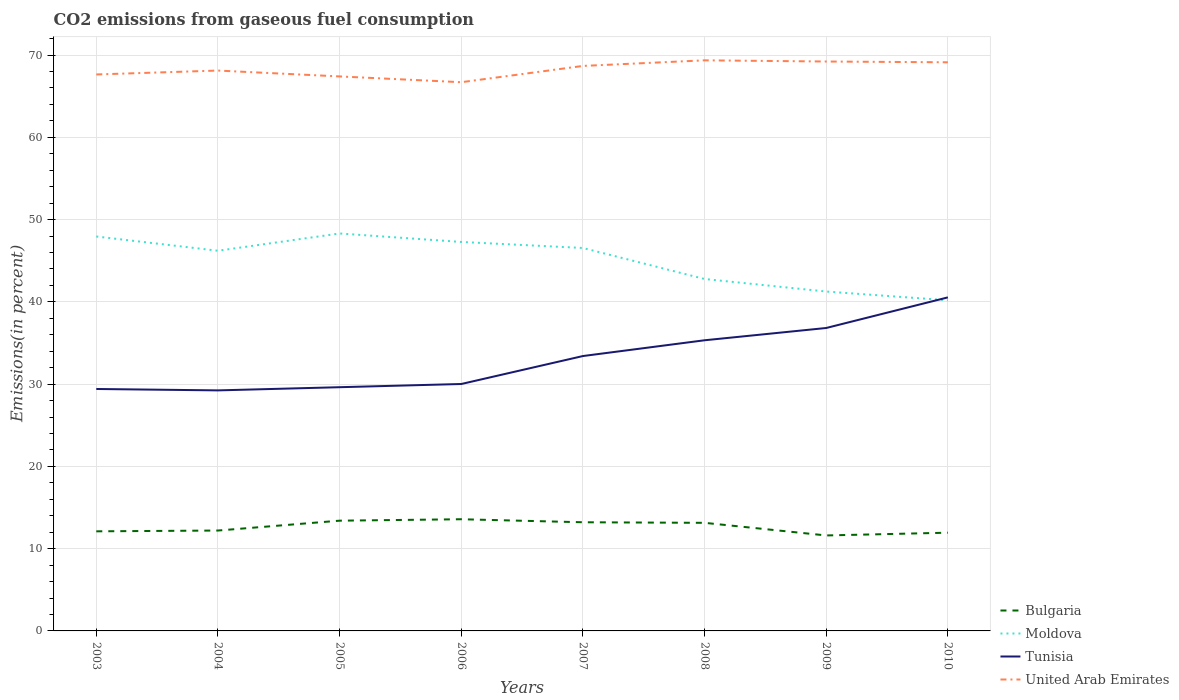Does the line corresponding to Tunisia intersect with the line corresponding to Moldova?
Ensure brevity in your answer.  Yes. Is the number of lines equal to the number of legend labels?
Your response must be concise. Yes. Across all years, what is the maximum total CO2 emitted in United Arab Emirates?
Offer a very short reply. 66.7. In which year was the total CO2 emitted in Moldova maximum?
Provide a short and direct response. 2010. What is the total total CO2 emitted in Tunisia in the graph?
Your answer should be very brief. -1.49. What is the difference between the highest and the second highest total CO2 emitted in Moldova?
Your answer should be compact. 8.12. What is the difference between the highest and the lowest total CO2 emitted in Moldova?
Offer a terse response. 5. How many lines are there?
Offer a very short reply. 4. Does the graph contain any zero values?
Ensure brevity in your answer.  No. How are the legend labels stacked?
Ensure brevity in your answer.  Vertical. What is the title of the graph?
Provide a succinct answer. CO2 emissions from gaseous fuel consumption. Does "Euro area" appear as one of the legend labels in the graph?
Keep it short and to the point. No. What is the label or title of the Y-axis?
Your answer should be compact. Emissions(in percent). What is the Emissions(in percent) in Bulgaria in 2003?
Ensure brevity in your answer.  12.11. What is the Emissions(in percent) of Moldova in 2003?
Offer a very short reply. 47.95. What is the Emissions(in percent) of Tunisia in 2003?
Ensure brevity in your answer.  29.41. What is the Emissions(in percent) in United Arab Emirates in 2003?
Keep it short and to the point. 67.64. What is the Emissions(in percent) in Bulgaria in 2004?
Offer a very short reply. 12.2. What is the Emissions(in percent) in Moldova in 2004?
Your answer should be compact. 46.22. What is the Emissions(in percent) in Tunisia in 2004?
Keep it short and to the point. 29.24. What is the Emissions(in percent) of United Arab Emirates in 2004?
Keep it short and to the point. 68.12. What is the Emissions(in percent) in Bulgaria in 2005?
Keep it short and to the point. 13.4. What is the Emissions(in percent) of Moldova in 2005?
Offer a terse response. 48.31. What is the Emissions(in percent) of Tunisia in 2005?
Provide a short and direct response. 29.63. What is the Emissions(in percent) in United Arab Emirates in 2005?
Your answer should be very brief. 67.41. What is the Emissions(in percent) of Bulgaria in 2006?
Your answer should be very brief. 13.58. What is the Emissions(in percent) in Moldova in 2006?
Make the answer very short. 47.28. What is the Emissions(in percent) in Tunisia in 2006?
Make the answer very short. 30.02. What is the Emissions(in percent) in United Arab Emirates in 2006?
Your answer should be compact. 66.7. What is the Emissions(in percent) of Bulgaria in 2007?
Give a very brief answer. 13.21. What is the Emissions(in percent) in Moldova in 2007?
Offer a terse response. 46.55. What is the Emissions(in percent) of Tunisia in 2007?
Your answer should be compact. 33.41. What is the Emissions(in percent) in United Arab Emirates in 2007?
Provide a succinct answer. 68.68. What is the Emissions(in percent) of Bulgaria in 2008?
Offer a terse response. 13.14. What is the Emissions(in percent) in Moldova in 2008?
Your answer should be compact. 42.78. What is the Emissions(in percent) of Tunisia in 2008?
Give a very brief answer. 35.33. What is the Emissions(in percent) in United Arab Emirates in 2008?
Make the answer very short. 69.36. What is the Emissions(in percent) in Bulgaria in 2009?
Ensure brevity in your answer.  11.61. What is the Emissions(in percent) in Moldova in 2009?
Your answer should be very brief. 41.26. What is the Emissions(in percent) of Tunisia in 2009?
Keep it short and to the point. 36.82. What is the Emissions(in percent) in United Arab Emirates in 2009?
Give a very brief answer. 69.22. What is the Emissions(in percent) of Bulgaria in 2010?
Offer a terse response. 11.94. What is the Emissions(in percent) of Moldova in 2010?
Provide a short and direct response. 40.19. What is the Emissions(in percent) in Tunisia in 2010?
Make the answer very short. 40.55. What is the Emissions(in percent) of United Arab Emirates in 2010?
Make the answer very short. 69.12. Across all years, what is the maximum Emissions(in percent) in Bulgaria?
Your answer should be very brief. 13.58. Across all years, what is the maximum Emissions(in percent) of Moldova?
Your response must be concise. 48.31. Across all years, what is the maximum Emissions(in percent) in Tunisia?
Provide a succinct answer. 40.55. Across all years, what is the maximum Emissions(in percent) of United Arab Emirates?
Offer a very short reply. 69.36. Across all years, what is the minimum Emissions(in percent) in Bulgaria?
Offer a terse response. 11.61. Across all years, what is the minimum Emissions(in percent) in Moldova?
Your answer should be very brief. 40.19. Across all years, what is the minimum Emissions(in percent) in Tunisia?
Your response must be concise. 29.24. Across all years, what is the minimum Emissions(in percent) of United Arab Emirates?
Give a very brief answer. 66.7. What is the total Emissions(in percent) in Bulgaria in the graph?
Offer a terse response. 101.19. What is the total Emissions(in percent) in Moldova in the graph?
Provide a short and direct response. 360.54. What is the total Emissions(in percent) of Tunisia in the graph?
Your answer should be very brief. 264.41. What is the total Emissions(in percent) of United Arab Emirates in the graph?
Your answer should be very brief. 546.26. What is the difference between the Emissions(in percent) of Bulgaria in 2003 and that in 2004?
Offer a terse response. -0.1. What is the difference between the Emissions(in percent) in Moldova in 2003 and that in 2004?
Keep it short and to the point. 1.73. What is the difference between the Emissions(in percent) in Tunisia in 2003 and that in 2004?
Your answer should be very brief. 0.17. What is the difference between the Emissions(in percent) in United Arab Emirates in 2003 and that in 2004?
Provide a short and direct response. -0.47. What is the difference between the Emissions(in percent) in Bulgaria in 2003 and that in 2005?
Give a very brief answer. -1.29. What is the difference between the Emissions(in percent) in Moldova in 2003 and that in 2005?
Provide a succinct answer. -0.37. What is the difference between the Emissions(in percent) in Tunisia in 2003 and that in 2005?
Keep it short and to the point. -0.22. What is the difference between the Emissions(in percent) of United Arab Emirates in 2003 and that in 2005?
Offer a terse response. 0.24. What is the difference between the Emissions(in percent) in Bulgaria in 2003 and that in 2006?
Give a very brief answer. -1.47. What is the difference between the Emissions(in percent) of Moldova in 2003 and that in 2006?
Provide a short and direct response. 0.67. What is the difference between the Emissions(in percent) of Tunisia in 2003 and that in 2006?
Provide a succinct answer. -0.61. What is the difference between the Emissions(in percent) in United Arab Emirates in 2003 and that in 2006?
Keep it short and to the point. 0.94. What is the difference between the Emissions(in percent) of Bulgaria in 2003 and that in 2007?
Provide a short and direct response. -1.1. What is the difference between the Emissions(in percent) of Moldova in 2003 and that in 2007?
Offer a terse response. 1.4. What is the difference between the Emissions(in percent) of Tunisia in 2003 and that in 2007?
Provide a succinct answer. -4. What is the difference between the Emissions(in percent) in United Arab Emirates in 2003 and that in 2007?
Ensure brevity in your answer.  -1.04. What is the difference between the Emissions(in percent) of Bulgaria in 2003 and that in 2008?
Your answer should be very brief. -1.03. What is the difference between the Emissions(in percent) in Moldova in 2003 and that in 2008?
Ensure brevity in your answer.  5.17. What is the difference between the Emissions(in percent) of Tunisia in 2003 and that in 2008?
Your answer should be very brief. -5.92. What is the difference between the Emissions(in percent) in United Arab Emirates in 2003 and that in 2008?
Give a very brief answer. -1.72. What is the difference between the Emissions(in percent) of Bulgaria in 2003 and that in 2009?
Give a very brief answer. 0.5. What is the difference between the Emissions(in percent) in Moldova in 2003 and that in 2009?
Your answer should be very brief. 6.69. What is the difference between the Emissions(in percent) in Tunisia in 2003 and that in 2009?
Offer a terse response. -7.42. What is the difference between the Emissions(in percent) of United Arab Emirates in 2003 and that in 2009?
Your answer should be very brief. -1.57. What is the difference between the Emissions(in percent) of Bulgaria in 2003 and that in 2010?
Ensure brevity in your answer.  0.17. What is the difference between the Emissions(in percent) in Moldova in 2003 and that in 2010?
Your answer should be very brief. 7.76. What is the difference between the Emissions(in percent) in Tunisia in 2003 and that in 2010?
Make the answer very short. -11.14. What is the difference between the Emissions(in percent) in United Arab Emirates in 2003 and that in 2010?
Ensure brevity in your answer.  -1.48. What is the difference between the Emissions(in percent) of Bulgaria in 2004 and that in 2005?
Your response must be concise. -1.2. What is the difference between the Emissions(in percent) of Moldova in 2004 and that in 2005?
Your answer should be very brief. -2.1. What is the difference between the Emissions(in percent) in Tunisia in 2004 and that in 2005?
Ensure brevity in your answer.  -0.39. What is the difference between the Emissions(in percent) of United Arab Emirates in 2004 and that in 2005?
Make the answer very short. 0.71. What is the difference between the Emissions(in percent) of Bulgaria in 2004 and that in 2006?
Make the answer very short. -1.37. What is the difference between the Emissions(in percent) of Moldova in 2004 and that in 2006?
Offer a very short reply. -1.07. What is the difference between the Emissions(in percent) of Tunisia in 2004 and that in 2006?
Your response must be concise. -0.78. What is the difference between the Emissions(in percent) in United Arab Emirates in 2004 and that in 2006?
Your response must be concise. 1.42. What is the difference between the Emissions(in percent) of Bulgaria in 2004 and that in 2007?
Give a very brief answer. -1.01. What is the difference between the Emissions(in percent) in Moldova in 2004 and that in 2007?
Keep it short and to the point. -0.34. What is the difference between the Emissions(in percent) of Tunisia in 2004 and that in 2007?
Offer a very short reply. -4.18. What is the difference between the Emissions(in percent) in United Arab Emirates in 2004 and that in 2007?
Your response must be concise. -0.56. What is the difference between the Emissions(in percent) of Bulgaria in 2004 and that in 2008?
Provide a succinct answer. -0.94. What is the difference between the Emissions(in percent) in Moldova in 2004 and that in 2008?
Provide a short and direct response. 3.44. What is the difference between the Emissions(in percent) of Tunisia in 2004 and that in 2008?
Provide a succinct answer. -6.09. What is the difference between the Emissions(in percent) of United Arab Emirates in 2004 and that in 2008?
Keep it short and to the point. -1.24. What is the difference between the Emissions(in percent) of Bulgaria in 2004 and that in 2009?
Keep it short and to the point. 0.6. What is the difference between the Emissions(in percent) of Moldova in 2004 and that in 2009?
Give a very brief answer. 4.96. What is the difference between the Emissions(in percent) in Tunisia in 2004 and that in 2009?
Provide a short and direct response. -7.59. What is the difference between the Emissions(in percent) in United Arab Emirates in 2004 and that in 2009?
Offer a terse response. -1.1. What is the difference between the Emissions(in percent) of Bulgaria in 2004 and that in 2010?
Give a very brief answer. 0.26. What is the difference between the Emissions(in percent) of Moldova in 2004 and that in 2010?
Ensure brevity in your answer.  6.02. What is the difference between the Emissions(in percent) of Tunisia in 2004 and that in 2010?
Offer a terse response. -11.31. What is the difference between the Emissions(in percent) in United Arab Emirates in 2004 and that in 2010?
Keep it short and to the point. -1. What is the difference between the Emissions(in percent) of Bulgaria in 2005 and that in 2006?
Offer a terse response. -0.17. What is the difference between the Emissions(in percent) of Moldova in 2005 and that in 2006?
Ensure brevity in your answer.  1.03. What is the difference between the Emissions(in percent) of Tunisia in 2005 and that in 2006?
Provide a short and direct response. -0.39. What is the difference between the Emissions(in percent) in United Arab Emirates in 2005 and that in 2006?
Offer a very short reply. 0.7. What is the difference between the Emissions(in percent) in Bulgaria in 2005 and that in 2007?
Your answer should be very brief. 0.19. What is the difference between the Emissions(in percent) of Moldova in 2005 and that in 2007?
Provide a short and direct response. 1.76. What is the difference between the Emissions(in percent) in Tunisia in 2005 and that in 2007?
Offer a very short reply. -3.79. What is the difference between the Emissions(in percent) of United Arab Emirates in 2005 and that in 2007?
Ensure brevity in your answer.  -1.28. What is the difference between the Emissions(in percent) in Bulgaria in 2005 and that in 2008?
Give a very brief answer. 0.26. What is the difference between the Emissions(in percent) of Moldova in 2005 and that in 2008?
Provide a succinct answer. 5.53. What is the difference between the Emissions(in percent) in Tunisia in 2005 and that in 2008?
Provide a short and direct response. -5.7. What is the difference between the Emissions(in percent) of United Arab Emirates in 2005 and that in 2008?
Your answer should be very brief. -1.96. What is the difference between the Emissions(in percent) of Bulgaria in 2005 and that in 2009?
Provide a short and direct response. 1.8. What is the difference between the Emissions(in percent) of Moldova in 2005 and that in 2009?
Make the answer very short. 7.06. What is the difference between the Emissions(in percent) of Tunisia in 2005 and that in 2009?
Your response must be concise. -7.2. What is the difference between the Emissions(in percent) of United Arab Emirates in 2005 and that in 2009?
Provide a short and direct response. -1.81. What is the difference between the Emissions(in percent) in Bulgaria in 2005 and that in 2010?
Give a very brief answer. 1.46. What is the difference between the Emissions(in percent) in Moldova in 2005 and that in 2010?
Your answer should be very brief. 8.12. What is the difference between the Emissions(in percent) of Tunisia in 2005 and that in 2010?
Provide a short and direct response. -10.92. What is the difference between the Emissions(in percent) of United Arab Emirates in 2005 and that in 2010?
Ensure brevity in your answer.  -1.72. What is the difference between the Emissions(in percent) in Bulgaria in 2006 and that in 2007?
Your response must be concise. 0.37. What is the difference between the Emissions(in percent) of Moldova in 2006 and that in 2007?
Your answer should be very brief. 0.73. What is the difference between the Emissions(in percent) of Tunisia in 2006 and that in 2007?
Offer a very short reply. -3.4. What is the difference between the Emissions(in percent) of United Arab Emirates in 2006 and that in 2007?
Your response must be concise. -1.98. What is the difference between the Emissions(in percent) of Bulgaria in 2006 and that in 2008?
Make the answer very short. 0.44. What is the difference between the Emissions(in percent) in Moldova in 2006 and that in 2008?
Ensure brevity in your answer.  4.5. What is the difference between the Emissions(in percent) in Tunisia in 2006 and that in 2008?
Keep it short and to the point. -5.32. What is the difference between the Emissions(in percent) in United Arab Emirates in 2006 and that in 2008?
Offer a terse response. -2.66. What is the difference between the Emissions(in percent) of Bulgaria in 2006 and that in 2009?
Keep it short and to the point. 1.97. What is the difference between the Emissions(in percent) in Moldova in 2006 and that in 2009?
Offer a terse response. 6.03. What is the difference between the Emissions(in percent) in Tunisia in 2006 and that in 2009?
Your response must be concise. -6.81. What is the difference between the Emissions(in percent) of United Arab Emirates in 2006 and that in 2009?
Make the answer very short. -2.52. What is the difference between the Emissions(in percent) in Bulgaria in 2006 and that in 2010?
Make the answer very short. 1.63. What is the difference between the Emissions(in percent) of Moldova in 2006 and that in 2010?
Offer a terse response. 7.09. What is the difference between the Emissions(in percent) of Tunisia in 2006 and that in 2010?
Ensure brevity in your answer.  -10.53. What is the difference between the Emissions(in percent) in United Arab Emirates in 2006 and that in 2010?
Keep it short and to the point. -2.42. What is the difference between the Emissions(in percent) in Bulgaria in 2007 and that in 2008?
Give a very brief answer. 0.07. What is the difference between the Emissions(in percent) in Moldova in 2007 and that in 2008?
Provide a short and direct response. 3.77. What is the difference between the Emissions(in percent) in Tunisia in 2007 and that in 2008?
Offer a terse response. -1.92. What is the difference between the Emissions(in percent) of United Arab Emirates in 2007 and that in 2008?
Offer a terse response. -0.68. What is the difference between the Emissions(in percent) in Bulgaria in 2007 and that in 2009?
Your answer should be very brief. 1.6. What is the difference between the Emissions(in percent) in Moldova in 2007 and that in 2009?
Provide a succinct answer. 5.29. What is the difference between the Emissions(in percent) in Tunisia in 2007 and that in 2009?
Your answer should be very brief. -3.41. What is the difference between the Emissions(in percent) of United Arab Emirates in 2007 and that in 2009?
Offer a terse response. -0.54. What is the difference between the Emissions(in percent) of Bulgaria in 2007 and that in 2010?
Give a very brief answer. 1.27. What is the difference between the Emissions(in percent) of Moldova in 2007 and that in 2010?
Provide a succinct answer. 6.36. What is the difference between the Emissions(in percent) in Tunisia in 2007 and that in 2010?
Offer a terse response. -7.13. What is the difference between the Emissions(in percent) in United Arab Emirates in 2007 and that in 2010?
Ensure brevity in your answer.  -0.44. What is the difference between the Emissions(in percent) of Bulgaria in 2008 and that in 2009?
Provide a succinct answer. 1.53. What is the difference between the Emissions(in percent) of Moldova in 2008 and that in 2009?
Your answer should be compact. 1.52. What is the difference between the Emissions(in percent) in Tunisia in 2008 and that in 2009?
Ensure brevity in your answer.  -1.49. What is the difference between the Emissions(in percent) in United Arab Emirates in 2008 and that in 2009?
Your response must be concise. 0.14. What is the difference between the Emissions(in percent) in Bulgaria in 2008 and that in 2010?
Offer a terse response. 1.2. What is the difference between the Emissions(in percent) in Moldova in 2008 and that in 2010?
Offer a very short reply. 2.59. What is the difference between the Emissions(in percent) of Tunisia in 2008 and that in 2010?
Provide a short and direct response. -5.21. What is the difference between the Emissions(in percent) of United Arab Emirates in 2008 and that in 2010?
Provide a short and direct response. 0.24. What is the difference between the Emissions(in percent) in Bulgaria in 2009 and that in 2010?
Offer a terse response. -0.34. What is the difference between the Emissions(in percent) in Moldova in 2009 and that in 2010?
Provide a short and direct response. 1.06. What is the difference between the Emissions(in percent) in Tunisia in 2009 and that in 2010?
Provide a short and direct response. -3.72. What is the difference between the Emissions(in percent) in United Arab Emirates in 2009 and that in 2010?
Make the answer very short. 0.1. What is the difference between the Emissions(in percent) of Bulgaria in 2003 and the Emissions(in percent) of Moldova in 2004?
Offer a terse response. -34.11. What is the difference between the Emissions(in percent) in Bulgaria in 2003 and the Emissions(in percent) in Tunisia in 2004?
Make the answer very short. -17.13. What is the difference between the Emissions(in percent) in Bulgaria in 2003 and the Emissions(in percent) in United Arab Emirates in 2004?
Your answer should be compact. -56.01. What is the difference between the Emissions(in percent) in Moldova in 2003 and the Emissions(in percent) in Tunisia in 2004?
Make the answer very short. 18.71. What is the difference between the Emissions(in percent) in Moldova in 2003 and the Emissions(in percent) in United Arab Emirates in 2004?
Keep it short and to the point. -20.17. What is the difference between the Emissions(in percent) in Tunisia in 2003 and the Emissions(in percent) in United Arab Emirates in 2004?
Ensure brevity in your answer.  -38.71. What is the difference between the Emissions(in percent) of Bulgaria in 2003 and the Emissions(in percent) of Moldova in 2005?
Your answer should be very brief. -36.21. What is the difference between the Emissions(in percent) in Bulgaria in 2003 and the Emissions(in percent) in Tunisia in 2005?
Your answer should be very brief. -17.52. What is the difference between the Emissions(in percent) in Bulgaria in 2003 and the Emissions(in percent) in United Arab Emirates in 2005?
Give a very brief answer. -55.3. What is the difference between the Emissions(in percent) of Moldova in 2003 and the Emissions(in percent) of Tunisia in 2005?
Make the answer very short. 18.32. What is the difference between the Emissions(in percent) in Moldova in 2003 and the Emissions(in percent) in United Arab Emirates in 2005?
Offer a terse response. -19.46. What is the difference between the Emissions(in percent) of Tunisia in 2003 and the Emissions(in percent) of United Arab Emirates in 2005?
Keep it short and to the point. -38. What is the difference between the Emissions(in percent) in Bulgaria in 2003 and the Emissions(in percent) in Moldova in 2006?
Offer a terse response. -35.18. What is the difference between the Emissions(in percent) in Bulgaria in 2003 and the Emissions(in percent) in Tunisia in 2006?
Give a very brief answer. -17.91. What is the difference between the Emissions(in percent) of Bulgaria in 2003 and the Emissions(in percent) of United Arab Emirates in 2006?
Offer a very short reply. -54.6. What is the difference between the Emissions(in percent) of Moldova in 2003 and the Emissions(in percent) of Tunisia in 2006?
Offer a very short reply. 17.93. What is the difference between the Emissions(in percent) of Moldova in 2003 and the Emissions(in percent) of United Arab Emirates in 2006?
Give a very brief answer. -18.75. What is the difference between the Emissions(in percent) in Tunisia in 2003 and the Emissions(in percent) in United Arab Emirates in 2006?
Your response must be concise. -37.29. What is the difference between the Emissions(in percent) in Bulgaria in 2003 and the Emissions(in percent) in Moldova in 2007?
Give a very brief answer. -34.44. What is the difference between the Emissions(in percent) of Bulgaria in 2003 and the Emissions(in percent) of Tunisia in 2007?
Offer a very short reply. -21.31. What is the difference between the Emissions(in percent) in Bulgaria in 2003 and the Emissions(in percent) in United Arab Emirates in 2007?
Ensure brevity in your answer.  -56.57. What is the difference between the Emissions(in percent) of Moldova in 2003 and the Emissions(in percent) of Tunisia in 2007?
Ensure brevity in your answer.  14.53. What is the difference between the Emissions(in percent) of Moldova in 2003 and the Emissions(in percent) of United Arab Emirates in 2007?
Give a very brief answer. -20.73. What is the difference between the Emissions(in percent) in Tunisia in 2003 and the Emissions(in percent) in United Arab Emirates in 2007?
Ensure brevity in your answer.  -39.27. What is the difference between the Emissions(in percent) of Bulgaria in 2003 and the Emissions(in percent) of Moldova in 2008?
Keep it short and to the point. -30.67. What is the difference between the Emissions(in percent) of Bulgaria in 2003 and the Emissions(in percent) of Tunisia in 2008?
Your answer should be compact. -23.22. What is the difference between the Emissions(in percent) of Bulgaria in 2003 and the Emissions(in percent) of United Arab Emirates in 2008?
Keep it short and to the point. -57.25. What is the difference between the Emissions(in percent) of Moldova in 2003 and the Emissions(in percent) of Tunisia in 2008?
Your response must be concise. 12.62. What is the difference between the Emissions(in percent) of Moldova in 2003 and the Emissions(in percent) of United Arab Emirates in 2008?
Give a very brief answer. -21.41. What is the difference between the Emissions(in percent) of Tunisia in 2003 and the Emissions(in percent) of United Arab Emirates in 2008?
Ensure brevity in your answer.  -39.95. What is the difference between the Emissions(in percent) of Bulgaria in 2003 and the Emissions(in percent) of Moldova in 2009?
Provide a succinct answer. -29.15. What is the difference between the Emissions(in percent) in Bulgaria in 2003 and the Emissions(in percent) in Tunisia in 2009?
Offer a terse response. -24.72. What is the difference between the Emissions(in percent) of Bulgaria in 2003 and the Emissions(in percent) of United Arab Emirates in 2009?
Your answer should be compact. -57.11. What is the difference between the Emissions(in percent) in Moldova in 2003 and the Emissions(in percent) in Tunisia in 2009?
Provide a succinct answer. 11.12. What is the difference between the Emissions(in percent) in Moldova in 2003 and the Emissions(in percent) in United Arab Emirates in 2009?
Make the answer very short. -21.27. What is the difference between the Emissions(in percent) in Tunisia in 2003 and the Emissions(in percent) in United Arab Emirates in 2009?
Your answer should be compact. -39.81. What is the difference between the Emissions(in percent) of Bulgaria in 2003 and the Emissions(in percent) of Moldova in 2010?
Offer a terse response. -28.09. What is the difference between the Emissions(in percent) of Bulgaria in 2003 and the Emissions(in percent) of Tunisia in 2010?
Give a very brief answer. -28.44. What is the difference between the Emissions(in percent) of Bulgaria in 2003 and the Emissions(in percent) of United Arab Emirates in 2010?
Keep it short and to the point. -57.02. What is the difference between the Emissions(in percent) in Moldova in 2003 and the Emissions(in percent) in Tunisia in 2010?
Your response must be concise. 7.4. What is the difference between the Emissions(in percent) in Moldova in 2003 and the Emissions(in percent) in United Arab Emirates in 2010?
Your answer should be compact. -21.17. What is the difference between the Emissions(in percent) of Tunisia in 2003 and the Emissions(in percent) of United Arab Emirates in 2010?
Give a very brief answer. -39.71. What is the difference between the Emissions(in percent) of Bulgaria in 2004 and the Emissions(in percent) of Moldova in 2005?
Make the answer very short. -36.11. What is the difference between the Emissions(in percent) in Bulgaria in 2004 and the Emissions(in percent) in Tunisia in 2005?
Your answer should be very brief. -17.42. What is the difference between the Emissions(in percent) of Bulgaria in 2004 and the Emissions(in percent) of United Arab Emirates in 2005?
Ensure brevity in your answer.  -55.2. What is the difference between the Emissions(in percent) of Moldova in 2004 and the Emissions(in percent) of Tunisia in 2005?
Provide a succinct answer. 16.59. What is the difference between the Emissions(in percent) of Moldova in 2004 and the Emissions(in percent) of United Arab Emirates in 2005?
Your response must be concise. -21.19. What is the difference between the Emissions(in percent) of Tunisia in 2004 and the Emissions(in percent) of United Arab Emirates in 2005?
Ensure brevity in your answer.  -38.17. What is the difference between the Emissions(in percent) of Bulgaria in 2004 and the Emissions(in percent) of Moldova in 2006?
Give a very brief answer. -35.08. What is the difference between the Emissions(in percent) of Bulgaria in 2004 and the Emissions(in percent) of Tunisia in 2006?
Keep it short and to the point. -17.81. What is the difference between the Emissions(in percent) of Bulgaria in 2004 and the Emissions(in percent) of United Arab Emirates in 2006?
Provide a short and direct response. -54.5. What is the difference between the Emissions(in percent) in Moldova in 2004 and the Emissions(in percent) in Tunisia in 2006?
Provide a succinct answer. 16.2. What is the difference between the Emissions(in percent) of Moldova in 2004 and the Emissions(in percent) of United Arab Emirates in 2006?
Offer a very short reply. -20.49. What is the difference between the Emissions(in percent) in Tunisia in 2004 and the Emissions(in percent) in United Arab Emirates in 2006?
Your response must be concise. -37.46. What is the difference between the Emissions(in percent) in Bulgaria in 2004 and the Emissions(in percent) in Moldova in 2007?
Provide a short and direct response. -34.35. What is the difference between the Emissions(in percent) in Bulgaria in 2004 and the Emissions(in percent) in Tunisia in 2007?
Provide a short and direct response. -21.21. What is the difference between the Emissions(in percent) of Bulgaria in 2004 and the Emissions(in percent) of United Arab Emirates in 2007?
Provide a succinct answer. -56.48. What is the difference between the Emissions(in percent) in Moldova in 2004 and the Emissions(in percent) in Tunisia in 2007?
Ensure brevity in your answer.  12.8. What is the difference between the Emissions(in percent) of Moldova in 2004 and the Emissions(in percent) of United Arab Emirates in 2007?
Provide a succinct answer. -22.47. What is the difference between the Emissions(in percent) in Tunisia in 2004 and the Emissions(in percent) in United Arab Emirates in 2007?
Ensure brevity in your answer.  -39.44. What is the difference between the Emissions(in percent) in Bulgaria in 2004 and the Emissions(in percent) in Moldova in 2008?
Make the answer very short. -30.58. What is the difference between the Emissions(in percent) of Bulgaria in 2004 and the Emissions(in percent) of Tunisia in 2008?
Give a very brief answer. -23.13. What is the difference between the Emissions(in percent) in Bulgaria in 2004 and the Emissions(in percent) in United Arab Emirates in 2008?
Your answer should be compact. -57.16. What is the difference between the Emissions(in percent) in Moldova in 2004 and the Emissions(in percent) in Tunisia in 2008?
Ensure brevity in your answer.  10.88. What is the difference between the Emissions(in percent) in Moldova in 2004 and the Emissions(in percent) in United Arab Emirates in 2008?
Your response must be concise. -23.15. What is the difference between the Emissions(in percent) in Tunisia in 2004 and the Emissions(in percent) in United Arab Emirates in 2008?
Offer a very short reply. -40.12. What is the difference between the Emissions(in percent) of Bulgaria in 2004 and the Emissions(in percent) of Moldova in 2009?
Offer a terse response. -29.05. What is the difference between the Emissions(in percent) of Bulgaria in 2004 and the Emissions(in percent) of Tunisia in 2009?
Your answer should be very brief. -24.62. What is the difference between the Emissions(in percent) of Bulgaria in 2004 and the Emissions(in percent) of United Arab Emirates in 2009?
Offer a very short reply. -57.02. What is the difference between the Emissions(in percent) in Moldova in 2004 and the Emissions(in percent) in Tunisia in 2009?
Give a very brief answer. 9.39. What is the difference between the Emissions(in percent) of Moldova in 2004 and the Emissions(in percent) of United Arab Emirates in 2009?
Your response must be concise. -23. What is the difference between the Emissions(in percent) of Tunisia in 2004 and the Emissions(in percent) of United Arab Emirates in 2009?
Provide a succinct answer. -39.98. What is the difference between the Emissions(in percent) in Bulgaria in 2004 and the Emissions(in percent) in Moldova in 2010?
Provide a succinct answer. -27.99. What is the difference between the Emissions(in percent) in Bulgaria in 2004 and the Emissions(in percent) in Tunisia in 2010?
Give a very brief answer. -28.34. What is the difference between the Emissions(in percent) in Bulgaria in 2004 and the Emissions(in percent) in United Arab Emirates in 2010?
Keep it short and to the point. -56.92. What is the difference between the Emissions(in percent) of Moldova in 2004 and the Emissions(in percent) of Tunisia in 2010?
Give a very brief answer. 5.67. What is the difference between the Emissions(in percent) of Moldova in 2004 and the Emissions(in percent) of United Arab Emirates in 2010?
Your answer should be compact. -22.91. What is the difference between the Emissions(in percent) of Tunisia in 2004 and the Emissions(in percent) of United Arab Emirates in 2010?
Your response must be concise. -39.88. What is the difference between the Emissions(in percent) in Bulgaria in 2005 and the Emissions(in percent) in Moldova in 2006?
Your response must be concise. -33.88. What is the difference between the Emissions(in percent) of Bulgaria in 2005 and the Emissions(in percent) of Tunisia in 2006?
Your answer should be compact. -16.61. What is the difference between the Emissions(in percent) in Bulgaria in 2005 and the Emissions(in percent) in United Arab Emirates in 2006?
Keep it short and to the point. -53.3. What is the difference between the Emissions(in percent) in Moldova in 2005 and the Emissions(in percent) in Tunisia in 2006?
Your response must be concise. 18.3. What is the difference between the Emissions(in percent) in Moldova in 2005 and the Emissions(in percent) in United Arab Emirates in 2006?
Your answer should be very brief. -18.39. What is the difference between the Emissions(in percent) of Tunisia in 2005 and the Emissions(in percent) of United Arab Emirates in 2006?
Provide a succinct answer. -37.08. What is the difference between the Emissions(in percent) of Bulgaria in 2005 and the Emissions(in percent) of Moldova in 2007?
Offer a very short reply. -33.15. What is the difference between the Emissions(in percent) of Bulgaria in 2005 and the Emissions(in percent) of Tunisia in 2007?
Ensure brevity in your answer.  -20.01. What is the difference between the Emissions(in percent) of Bulgaria in 2005 and the Emissions(in percent) of United Arab Emirates in 2007?
Make the answer very short. -55.28. What is the difference between the Emissions(in percent) of Moldova in 2005 and the Emissions(in percent) of Tunisia in 2007?
Make the answer very short. 14.9. What is the difference between the Emissions(in percent) in Moldova in 2005 and the Emissions(in percent) in United Arab Emirates in 2007?
Give a very brief answer. -20.37. What is the difference between the Emissions(in percent) in Tunisia in 2005 and the Emissions(in percent) in United Arab Emirates in 2007?
Give a very brief answer. -39.05. What is the difference between the Emissions(in percent) in Bulgaria in 2005 and the Emissions(in percent) in Moldova in 2008?
Offer a very short reply. -29.38. What is the difference between the Emissions(in percent) of Bulgaria in 2005 and the Emissions(in percent) of Tunisia in 2008?
Offer a terse response. -21.93. What is the difference between the Emissions(in percent) of Bulgaria in 2005 and the Emissions(in percent) of United Arab Emirates in 2008?
Ensure brevity in your answer.  -55.96. What is the difference between the Emissions(in percent) in Moldova in 2005 and the Emissions(in percent) in Tunisia in 2008?
Your answer should be very brief. 12.98. What is the difference between the Emissions(in percent) in Moldova in 2005 and the Emissions(in percent) in United Arab Emirates in 2008?
Offer a very short reply. -21.05. What is the difference between the Emissions(in percent) of Tunisia in 2005 and the Emissions(in percent) of United Arab Emirates in 2008?
Offer a very short reply. -39.73. What is the difference between the Emissions(in percent) of Bulgaria in 2005 and the Emissions(in percent) of Moldova in 2009?
Your answer should be very brief. -27.85. What is the difference between the Emissions(in percent) of Bulgaria in 2005 and the Emissions(in percent) of Tunisia in 2009?
Keep it short and to the point. -23.42. What is the difference between the Emissions(in percent) of Bulgaria in 2005 and the Emissions(in percent) of United Arab Emirates in 2009?
Give a very brief answer. -55.82. What is the difference between the Emissions(in percent) in Moldova in 2005 and the Emissions(in percent) in Tunisia in 2009?
Keep it short and to the point. 11.49. What is the difference between the Emissions(in percent) in Moldova in 2005 and the Emissions(in percent) in United Arab Emirates in 2009?
Offer a very short reply. -20.9. What is the difference between the Emissions(in percent) in Tunisia in 2005 and the Emissions(in percent) in United Arab Emirates in 2009?
Make the answer very short. -39.59. What is the difference between the Emissions(in percent) of Bulgaria in 2005 and the Emissions(in percent) of Moldova in 2010?
Offer a very short reply. -26.79. What is the difference between the Emissions(in percent) in Bulgaria in 2005 and the Emissions(in percent) in Tunisia in 2010?
Give a very brief answer. -27.14. What is the difference between the Emissions(in percent) in Bulgaria in 2005 and the Emissions(in percent) in United Arab Emirates in 2010?
Provide a succinct answer. -55.72. What is the difference between the Emissions(in percent) in Moldova in 2005 and the Emissions(in percent) in Tunisia in 2010?
Your response must be concise. 7.77. What is the difference between the Emissions(in percent) of Moldova in 2005 and the Emissions(in percent) of United Arab Emirates in 2010?
Provide a short and direct response. -20.81. What is the difference between the Emissions(in percent) of Tunisia in 2005 and the Emissions(in percent) of United Arab Emirates in 2010?
Your response must be concise. -39.5. What is the difference between the Emissions(in percent) of Bulgaria in 2006 and the Emissions(in percent) of Moldova in 2007?
Make the answer very short. -32.98. What is the difference between the Emissions(in percent) in Bulgaria in 2006 and the Emissions(in percent) in Tunisia in 2007?
Offer a terse response. -19.84. What is the difference between the Emissions(in percent) in Bulgaria in 2006 and the Emissions(in percent) in United Arab Emirates in 2007?
Offer a very short reply. -55.11. What is the difference between the Emissions(in percent) in Moldova in 2006 and the Emissions(in percent) in Tunisia in 2007?
Offer a very short reply. 13.87. What is the difference between the Emissions(in percent) of Moldova in 2006 and the Emissions(in percent) of United Arab Emirates in 2007?
Your answer should be very brief. -21.4. What is the difference between the Emissions(in percent) of Tunisia in 2006 and the Emissions(in percent) of United Arab Emirates in 2007?
Give a very brief answer. -38.67. What is the difference between the Emissions(in percent) of Bulgaria in 2006 and the Emissions(in percent) of Moldova in 2008?
Give a very brief answer. -29.2. What is the difference between the Emissions(in percent) of Bulgaria in 2006 and the Emissions(in percent) of Tunisia in 2008?
Keep it short and to the point. -21.76. What is the difference between the Emissions(in percent) in Bulgaria in 2006 and the Emissions(in percent) in United Arab Emirates in 2008?
Provide a succinct answer. -55.79. What is the difference between the Emissions(in percent) in Moldova in 2006 and the Emissions(in percent) in Tunisia in 2008?
Ensure brevity in your answer.  11.95. What is the difference between the Emissions(in percent) of Moldova in 2006 and the Emissions(in percent) of United Arab Emirates in 2008?
Offer a terse response. -22.08. What is the difference between the Emissions(in percent) in Tunisia in 2006 and the Emissions(in percent) in United Arab Emirates in 2008?
Your answer should be very brief. -39.35. What is the difference between the Emissions(in percent) in Bulgaria in 2006 and the Emissions(in percent) in Moldova in 2009?
Give a very brief answer. -27.68. What is the difference between the Emissions(in percent) of Bulgaria in 2006 and the Emissions(in percent) of Tunisia in 2009?
Provide a short and direct response. -23.25. What is the difference between the Emissions(in percent) in Bulgaria in 2006 and the Emissions(in percent) in United Arab Emirates in 2009?
Ensure brevity in your answer.  -55.64. What is the difference between the Emissions(in percent) in Moldova in 2006 and the Emissions(in percent) in Tunisia in 2009?
Provide a succinct answer. 10.46. What is the difference between the Emissions(in percent) in Moldova in 2006 and the Emissions(in percent) in United Arab Emirates in 2009?
Keep it short and to the point. -21.94. What is the difference between the Emissions(in percent) of Tunisia in 2006 and the Emissions(in percent) of United Arab Emirates in 2009?
Your response must be concise. -39.2. What is the difference between the Emissions(in percent) of Bulgaria in 2006 and the Emissions(in percent) of Moldova in 2010?
Keep it short and to the point. -26.62. What is the difference between the Emissions(in percent) in Bulgaria in 2006 and the Emissions(in percent) in Tunisia in 2010?
Give a very brief answer. -26.97. What is the difference between the Emissions(in percent) of Bulgaria in 2006 and the Emissions(in percent) of United Arab Emirates in 2010?
Make the answer very short. -55.55. What is the difference between the Emissions(in percent) in Moldova in 2006 and the Emissions(in percent) in Tunisia in 2010?
Provide a succinct answer. 6.74. What is the difference between the Emissions(in percent) in Moldova in 2006 and the Emissions(in percent) in United Arab Emirates in 2010?
Your answer should be compact. -21.84. What is the difference between the Emissions(in percent) of Tunisia in 2006 and the Emissions(in percent) of United Arab Emirates in 2010?
Your response must be concise. -39.11. What is the difference between the Emissions(in percent) of Bulgaria in 2007 and the Emissions(in percent) of Moldova in 2008?
Ensure brevity in your answer.  -29.57. What is the difference between the Emissions(in percent) of Bulgaria in 2007 and the Emissions(in percent) of Tunisia in 2008?
Give a very brief answer. -22.12. What is the difference between the Emissions(in percent) of Bulgaria in 2007 and the Emissions(in percent) of United Arab Emirates in 2008?
Your answer should be very brief. -56.15. What is the difference between the Emissions(in percent) in Moldova in 2007 and the Emissions(in percent) in Tunisia in 2008?
Provide a succinct answer. 11.22. What is the difference between the Emissions(in percent) in Moldova in 2007 and the Emissions(in percent) in United Arab Emirates in 2008?
Make the answer very short. -22.81. What is the difference between the Emissions(in percent) of Tunisia in 2007 and the Emissions(in percent) of United Arab Emirates in 2008?
Keep it short and to the point. -35.95. What is the difference between the Emissions(in percent) of Bulgaria in 2007 and the Emissions(in percent) of Moldova in 2009?
Your answer should be compact. -28.05. What is the difference between the Emissions(in percent) in Bulgaria in 2007 and the Emissions(in percent) in Tunisia in 2009?
Ensure brevity in your answer.  -23.62. What is the difference between the Emissions(in percent) of Bulgaria in 2007 and the Emissions(in percent) of United Arab Emirates in 2009?
Give a very brief answer. -56.01. What is the difference between the Emissions(in percent) in Moldova in 2007 and the Emissions(in percent) in Tunisia in 2009?
Offer a very short reply. 9.73. What is the difference between the Emissions(in percent) of Moldova in 2007 and the Emissions(in percent) of United Arab Emirates in 2009?
Keep it short and to the point. -22.67. What is the difference between the Emissions(in percent) of Tunisia in 2007 and the Emissions(in percent) of United Arab Emirates in 2009?
Ensure brevity in your answer.  -35.8. What is the difference between the Emissions(in percent) of Bulgaria in 2007 and the Emissions(in percent) of Moldova in 2010?
Provide a short and direct response. -26.98. What is the difference between the Emissions(in percent) in Bulgaria in 2007 and the Emissions(in percent) in Tunisia in 2010?
Ensure brevity in your answer.  -27.34. What is the difference between the Emissions(in percent) in Bulgaria in 2007 and the Emissions(in percent) in United Arab Emirates in 2010?
Offer a very short reply. -55.91. What is the difference between the Emissions(in percent) of Moldova in 2007 and the Emissions(in percent) of Tunisia in 2010?
Provide a succinct answer. 6.01. What is the difference between the Emissions(in percent) in Moldova in 2007 and the Emissions(in percent) in United Arab Emirates in 2010?
Offer a terse response. -22.57. What is the difference between the Emissions(in percent) of Tunisia in 2007 and the Emissions(in percent) of United Arab Emirates in 2010?
Make the answer very short. -35.71. What is the difference between the Emissions(in percent) in Bulgaria in 2008 and the Emissions(in percent) in Moldova in 2009?
Provide a short and direct response. -28.12. What is the difference between the Emissions(in percent) of Bulgaria in 2008 and the Emissions(in percent) of Tunisia in 2009?
Offer a very short reply. -23.69. What is the difference between the Emissions(in percent) of Bulgaria in 2008 and the Emissions(in percent) of United Arab Emirates in 2009?
Offer a very short reply. -56.08. What is the difference between the Emissions(in percent) in Moldova in 2008 and the Emissions(in percent) in Tunisia in 2009?
Your answer should be compact. 5.96. What is the difference between the Emissions(in percent) of Moldova in 2008 and the Emissions(in percent) of United Arab Emirates in 2009?
Your response must be concise. -26.44. What is the difference between the Emissions(in percent) of Tunisia in 2008 and the Emissions(in percent) of United Arab Emirates in 2009?
Offer a terse response. -33.89. What is the difference between the Emissions(in percent) of Bulgaria in 2008 and the Emissions(in percent) of Moldova in 2010?
Provide a succinct answer. -27.05. What is the difference between the Emissions(in percent) in Bulgaria in 2008 and the Emissions(in percent) in Tunisia in 2010?
Give a very brief answer. -27.41. What is the difference between the Emissions(in percent) in Bulgaria in 2008 and the Emissions(in percent) in United Arab Emirates in 2010?
Offer a very short reply. -55.98. What is the difference between the Emissions(in percent) in Moldova in 2008 and the Emissions(in percent) in Tunisia in 2010?
Provide a short and direct response. 2.23. What is the difference between the Emissions(in percent) of Moldova in 2008 and the Emissions(in percent) of United Arab Emirates in 2010?
Give a very brief answer. -26.34. What is the difference between the Emissions(in percent) in Tunisia in 2008 and the Emissions(in percent) in United Arab Emirates in 2010?
Keep it short and to the point. -33.79. What is the difference between the Emissions(in percent) in Bulgaria in 2009 and the Emissions(in percent) in Moldova in 2010?
Provide a succinct answer. -28.59. What is the difference between the Emissions(in percent) in Bulgaria in 2009 and the Emissions(in percent) in Tunisia in 2010?
Your response must be concise. -28.94. What is the difference between the Emissions(in percent) of Bulgaria in 2009 and the Emissions(in percent) of United Arab Emirates in 2010?
Provide a short and direct response. -57.52. What is the difference between the Emissions(in percent) in Moldova in 2009 and the Emissions(in percent) in Tunisia in 2010?
Make the answer very short. 0.71. What is the difference between the Emissions(in percent) of Moldova in 2009 and the Emissions(in percent) of United Arab Emirates in 2010?
Your answer should be very brief. -27.87. What is the difference between the Emissions(in percent) of Tunisia in 2009 and the Emissions(in percent) of United Arab Emirates in 2010?
Provide a short and direct response. -32.3. What is the average Emissions(in percent) in Bulgaria per year?
Offer a terse response. 12.65. What is the average Emissions(in percent) in Moldova per year?
Your answer should be very brief. 45.07. What is the average Emissions(in percent) of Tunisia per year?
Keep it short and to the point. 33.05. What is the average Emissions(in percent) of United Arab Emirates per year?
Your answer should be compact. 68.28. In the year 2003, what is the difference between the Emissions(in percent) of Bulgaria and Emissions(in percent) of Moldova?
Provide a short and direct response. -35.84. In the year 2003, what is the difference between the Emissions(in percent) in Bulgaria and Emissions(in percent) in Tunisia?
Your answer should be compact. -17.3. In the year 2003, what is the difference between the Emissions(in percent) in Bulgaria and Emissions(in percent) in United Arab Emirates?
Give a very brief answer. -55.54. In the year 2003, what is the difference between the Emissions(in percent) in Moldova and Emissions(in percent) in Tunisia?
Provide a short and direct response. 18.54. In the year 2003, what is the difference between the Emissions(in percent) of Moldova and Emissions(in percent) of United Arab Emirates?
Your response must be concise. -19.7. In the year 2003, what is the difference between the Emissions(in percent) in Tunisia and Emissions(in percent) in United Arab Emirates?
Provide a succinct answer. -38.24. In the year 2004, what is the difference between the Emissions(in percent) in Bulgaria and Emissions(in percent) in Moldova?
Provide a short and direct response. -34.01. In the year 2004, what is the difference between the Emissions(in percent) of Bulgaria and Emissions(in percent) of Tunisia?
Provide a succinct answer. -17.04. In the year 2004, what is the difference between the Emissions(in percent) of Bulgaria and Emissions(in percent) of United Arab Emirates?
Your answer should be very brief. -55.92. In the year 2004, what is the difference between the Emissions(in percent) of Moldova and Emissions(in percent) of Tunisia?
Keep it short and to the point. 16.98. In the year 2004, what is the difference between the Emissions(in percent) in Moldova and Emissions(in percent) in United Arab Emirates?
Provide a short and direct response. -21.9. In the year 2004, what is the difference between the Emissions(in percent) in Tunisia and Emissions(in percent) in United Arab Emirates?
Provide a short and direct response. -38.88. In the year 2005, what is the difference between the Emissions(in percent) of Bulgaria and Emissions(in percent) of Moldova?
Offer a very short reply. -34.91. In the year 2005, what is the difference between the Emissions(in percent) of Bulgaria and Emissions(in percent) of Tunisia?
Provide a succinct answer. -16.23. In the year 2005, what is the difference between the Emissions(in percent) in Bulgaria and Emissions(in percent) in United Arab Emirates?
Offer a very short reply. -54. In the year 2005, what is the difference between the Emissions(in percent) of Moldova and Emissions(in percent) of Tunisia?
Your response must be concise. 18.69. In the year 2005, what is the difference between the Emissions(in percent) in Moldova and Emissions(in percent) in United Arab Emirates?
Make the answer very short. -19.09. In the year 2005, what is the difference between the Emissions(in percent) in Tunisia and Emissions(in percent) in United Arab Emirates?
Give a very brief answer. -37.78. In the year 2006, what is the difference between the Emissions(in percent) in Bulgaria and Emissions(in percent) in Moldova?
Give a very brief answer. -33.71. In the year 2006, what is the difference between the Emissions(in percent) in Bulgaria and Emissions(in percent) in Tunisia?
Offer a very short reply. -16.44. In the year 2006, what is the difference between the Emissions(in percent) of Bulgaria and Emissions(in percent) of United Arab Emirates?
Your response must be concise. -53.13. In the year 2006, what is the difference between the Emissions(in percent) in Moldova and Emissions(in percent) in Tunisia?
Give a very brief answer. 17.27. In the year 2006, what is the difference between the Emissions(in percent) in Moldova and Emissions(in percent) in United Arab Emirates?
Give a very brief answer. -19.42. In the year 2006, what is the difference between the Emissions(in percent) of Tunisia and Emissions(in percent) of United Arab Emirates?
Your answer should be compact. -36.69. In the year 2007, what is the difference between the Emissions(in percent) in Bulgaria and Emissions(in percent) in Moldova?
Offer a terse response. -33.34. In the year 2007, what is the difference between the Emissions(in percent) of Bulgaria and Emissions(in percent) of Tunisia?
Provide a succinct answer. -20.2. In the year 2007, what is the difference between the Emissions(in percent) in Bulgaria and Emissions(in percent) in United Arab Emirates?
Your answer should be compact. -55.47. In the year 2007, what is the difference between the Emissions(in percent) in Moldova and Emissions(in percent) in Tunisia?
Make the answer very short. 13.14. In the year 2007, what is the difference between the Emissions(in percent) of Moldova and Emissions(in percent) of United Arab Emirates?
Your response must be concise. -22.13. In the year 2007, what is the difference between the Emissions(in percent) in Tunisia and Emissions(in percent) in United Arab Emirates?
Your answer should be compact. -35.27. In the year 2008, what is the difference between the Emissions(in percent) in Bulgaria and Emissions(in percent) in Moldova?
Provide a short and direct response. -29.64. In the year 2008, what is the difference between the Emissions(in percent) in Bulgaria and Emissions(in percent) in Tunisia?
Your answer should be very brief. -22.19. In the year 2008, what is the difference between the Emissions(in percent) in Bulgaria and Emissions(in percent) in United Arab Emirates?
Ensure brevity in your answer.  -56.22. In the year 2008, what is the difference between the Emissions(in percent) in Moldova and Emissions(in percent) in Tunisia?
Make the answer very short. 7.45. In the year 2008, what is the difference between the Emissions(in percent) of Moldova and Emissions(in percent) of United Arab Emirates?
Provide a short and direct response. -26.58. In the year 2008, what is the difference between the Emissions(in percent) in Tunisia and Emissions(in percent) in United Arab Emirates?
Your answer should be compact. -34.03. In the year 2009, what is the difference between the Emissions(in percent) in Bulgaria and Emissions(in percent) in Moldova?
Provide a succinct answer. -29.65. In the year 2009, what is the difference between the Emissions(in percent) in Bulgaria and Emissions(in percent) in Tunisia?
Offer a terse response. -25.22. In the year 2009, what is the difference between the Emissions(in percent) of Bulgaria and Emissions(in percent) of United Arab Emirates?
Make the answer very short. -57.61. In the year 2009, what is the difference between the Emissions(in percent) in Moldova and Emissions(in percent) in Tunisia?
Provide a succinct answer. 4.43. In the year 2009, what is the difference between the Emissions(in percent) of Moldova and Emissions(in percent) of United Arab Emirates?
Your answer should be very brief. -27.96. In the year 2009, what is the difference between the Emissions(in percent) of Tunisia and Emissions(in percent) of United Arab Emirates?
Provide a short and direct response. -32.39. In the year 2010, what is the difference between the Emissions(in percent) in Bulgaria and Emissions(in percent) in Moldova?
Give a very brief answer. -28.25. In the year 2010, what is the difference between the Emissions(in percent) in Bulgaria and Emissions(in percent) in Tunisia?
Provide a succinct answer. -28.6. In the year 2010, what is the difference between the Emissions(in percent) in Bulgaria and Emissions(in percent) in United Arab Emirates?
Keep it short and to the point. -57.18. In the year 2010, what is the difference between the Emissions(in percent) of Moldova and Emissions(in percent) of Tunisia?
Give a very brief answer. -0.35. In the year 2010, what is the difference between the Emissions(in percent) of Moldova and Emissions(in percent) of United Arab Emirates?
Provide a succinct answer. -28.93. In the year 2010, what is the difference between the Emissions(in percent) of Tunisia and Emissions(in percent) of United Arab Emirates?
Make the answer very short. -28.58. What is the ratio of the Emissions(in percent) of Moldova in 2003 to that in 2004?
Your response must be concise. 1.04. What is the ratio of the Emissions(in percent) of Tunisia in 2003 to that in 2004?
Your response must be concise. 1.01. What is the ratio of the Emissions(in percent) of Bulgaria in 2003 to that in 2005?
Offer a very short reply. 0.9. What is the ratio of the Emissions(in percent) in Tunisia in 2003 to that in 2005?
Keep it short and to the point. 0.99. What is the ratio of the Emissions(in percent) in Bulgaria in 2003 to that in 2006?
Your response must be concise. 0.89. What is the ratio of the Emissions(in percent) in Moldova in 2003 to that in 2006?
Offer a terse response. 1.01. What is the ratio of the Emissions(in percent) in Tunisia in 2003 to that in 2006?
Offer a terse response. 0.98. What is the ratio of the Emissions(in percent) of United Arab Emirates in 2003 to that in 2006?
Provide a succinct answer. 1.01. What is the ratio of the Emissions(in percent) in Bulgaria in 2003 to that in 2007?
Keep it short and to the point. 0.92. What is the ratio of the Emissions(in percent) in Moldova in 2003 to that in 2007?
Provide a succinct answer. 1.03. What is the ratio of the Emissions(in percent) in Tunisia in 2003 to that in 2007?
Offer a terse response. 0.88. What is the ratio of the Emissions(in percent) in United Arab Emirates in 2003 to that in 2007?
Your answer should be very brief. 0.98. What is the ratio of the Emissions(in percent) of Bulgaria in 2003 to that in 2008?
Offer a terse response. 0.92. What is the ratio of the Emissions(in percent) in Moldova in 2003 to that in 2008?
Provide a short and direct response. 1.12. What is the ratio of the Emissions(in percent) of Tunisia in 2003 to that in 2008?
Provide a short and direct response. 0.83. What is the ratio of the Emissions(in percent) in United Arab Emirates in 2003 to that in 2008?
Make the answer very short. 0.98. What is the ratio of the Emissions(in percent) of Bulgaria in 2003 to that in 2009?
Offer a terse response. 1.04. What is the ratio of the Emissions(in percent) of Moldova in 2003 to that in 2009?
Your response must be concise. 1.16. What is the ratio of the Emissions(in percent) in Tunisia in 2003 to that in 2009?
Offer a very short reply. 0.8. What is the ratio of the Emissions(in percent) in United Arab Emirates in 2003 to that in 2009?
Make the answer very short. 0.98. What is the ratio of the Emissions(in percent) of Bulgaria in 2003 to that in 2010?
Your answer should be very brief. 1.01. What is the ratio of the Emissions(in percent) in Moldova in 2003 to that in 2010?
Offer a very short reply. 1.19. What is the ratio of the Emissions(in percent) of Tunisia in 2003 to that in 2010?
Your answer should be very brief. 0.73. What is the ratio of the Emissions(in percent) in United Arab Emirates in 2003 to that in 2010?
Your answer should be very brief. 0.98. What is the ratio of the Emissions(in percent) in Bulgaria in 2004 to that in 2005?
Your answer should be compact. 0.91. What is the ratio of the Emissions(in percent) in Moldova in 2004 to that in 2005?
Make the answer very short. 0.96. What is the ratio of the Emissions(in percent) of Tunisia in 2004 to that in 2005?
Offer a terse response. 0.99. What is the ratio of the Emissions(in percent) in United Arab Emirates in 2004 to that in 2005?
Your response must be concise. 1.01. What is the ratio of the Emissions(in percent) of Bulgaria in 2004 to that in 2006?
Your response must be concise. 0.9. What is the ratio of the Emissions(in percent) in Moldova in 2004 to that in 2006?
Keep it short and to the point. 0.98. What is the ratio of the Emissions(in percent) of Tunisia in 2004 to that in 2006?
Keep it short and to the point. 0.97. What is the ratio of the Emissions(in percent) in United Arab Emirates in 2004 to that in 2006?
Your answer should be very brief. 1.02. What is the ratio of the Emissions(in percent) in Bulgaria in 2004 to that in 2007?
Offer a terse response. 0.92. What is the ratio of the Emissions(in percent) of Tunisia in 2004 to that in 2007?
Your answer should be compact. 0.88. What is the ratio of the Emissions(in percent) of Bulgaria in 2004 to that in 2008?
Your answer should be very brief. 0.93. What is the ratio of the Emissions(in percent) in Moldova in 2004 to that in 2008?
Your response must be concise. 1.08. What is the ratio of the Emissions(in percent) of Tunisia in 2004 to that in 2008?
Provide a short and direct response. 0.83. What is the ratio of the Emissions(in percent) of United Arab Emirates in 2004 to that in 2008?
Make the answer very short. 0.98. What is the ratio of the Emissions(in percent) in Bulgaria in 2004 to that in 2009?
Your answer should be compact. 1.05. What is the ratio of the Emissions(in percent) of Moldova in 2004 to that in 2009?
Provide a short and direct response. 1.12. What is the ratio of the Emissions(in percent) of Tunisia in 2004 to that in 2009?
Your answer should be compact. 0.79. What is the ratio of the Emissions(in percent) of United Arab Emirates in 2004 to that in 2009?
Your answer should be compact. 0.98. What is the ratio of the Emissions(in percent) of Bulgaria in 2004 to that in 2010?
Offer a very short reply. 1.02. What is the ratio of the Emissions(in percent) of Moldova in 2004 to that in 2010?
Your answer should be very brief. 1.15. What is the ratio of the Emissions(in percent) of Tunisia in 2004 to that in 2010?
Offer a very short reply. 0.72. What is the ratio of the Emissions(in percent) of United Arab Emirates in 2004 to that in 2010?
Your response must be concise. 0.99. What is the ratio of the Emissions(in percent) of Bulgaria in 2005 to that in 2006?
Make the answer very short. 0.99. What is the ratio of the Emissions(in percent) of Moldova in 2005 to that in 2006?
Your response must be concise. 1.02. What is the ratio of the Emissions(in percent) in Tunisia in 2005 to that in 2006?
Ensure brevity in your answer.  0.99. What is the ratio of the Emissions(in percent) of United Arab Emirates in 2005 to that in 2006?
Provide a succinct answer. 1.01. What is the ratio of the Emissions(in percent) in Bulgaria in 2005 to that in 2007?
Your answer should be very brief. 1.01. What is the ratio of the Emissions(in percent) in Moldova in 2005 to that in 2007?
Give a very brief answer. 1.04. What is the ratio of the Emissions(in percent) of Tunisia in 2005 to that in 2007?
Keep it short and to the point. 0.89. What is the ratio of the Emissions(in percent) in United Arab Emirates in 2005 to that in 2007?
Provide a succinct answer. 0.98. What is the ratio of the Emissions(in percent) in Bulgaria in 2005 to that in 2008?
Your answer should be compact. 1.02. What is the ratio of the Emissions(in percent) of Moldova in 2005 to that in 2008?
Offer a very short reply. 1.13. What is the ratio of the Emissions(in percent) of Tunisia in 2005 to that in 2008?
Give a very brief answer. 0.84. What is the ratio of the Emissions(in percent) in United Arab Emirates in 2005 to that in 2008?
Your answer should be compact. 0.97. What is the ratio of the Emissions(in percent) of Bulgaria in 2005 to that in 2009?
Your answer should be compact. 1.15. What is the ratio of the Emissions(in percent) in Moldova in 2005 to that in 2009?
Ensure brevity in your answer.  1.17. What is the ratio of the Emissions(in percent) in Tunisia in 2005 to that in 2009?
Provide a succinct answer. 0.8. What is the ratio of the Emissions(in percent) of United Arab Emirates in 2005 to that in 2009?
Keep it short and to the point. 0.97. What is the ratio of the Emissions(in percent) in Bulgaria in 2005 to that in 2010?
Keep it short and to the point. 1.12. What is the ratio of the Emissions(in percent) in Moldova in 2005 to that in 2010?
Your answer should be compact. 1.2. What is the ratio of the Emissions(in percent) in Tunisia in 2005 to that in 2010?
Offer a terse response. 0.73. What is the ratio of the Emissions(in percent) of United Arab Emirates in 2005 to that in 2010?
Provide a succinct answer. 0.98. What is the ratio of the Emissions(in percent) in Bulgaria in 2006 to that in 2007?
Ensure brevity in your answer.  1.03. What is the ratio of the Emissions(in percent) in Moldova in 2006 to that in 2007?
Make the answer very short. 1.02. What is the ratio of the Emissions(in percent) of Tunisia in 2006 to that in 2007?
Ensure brevity in your answer.  0.9. What is the ratio of the Emissions(in percent) in United Arab Emirates in 2006 to that in 2007?
Your answer should be very brief. 0.97. What is the ratio of the Emissions(in percent) in Bulgaria in 2006 to that in 2008?
Your answer should be compact. 1.03. What is the ratio of the Emissions(in percent) in Moldova in 2006 to that in 2008?
Offer a terse response. 1.11. What is the ratio of the Emissions(in percent) in Tunisia in 2006 to that in 2008?
Offer a very short reply. 0.85. What is the ratio of the Emissions(in percent) of United Arab Emirates in 2006 to that in 2008?
Make the answer very short. 0.96. What is the ratio of the Emissions(in percent) in Bulgaria in 2006 to that in 2009?
Your answer should be very brief. 1.17. What is the ratio of the Emissions(in percent) in Moldova in 2006 to that in 2009?
Ensure brevity in your answer.  1.15. What is the ratio of the Emissions(in percent) of Tunisia in 2006 to that in 2009?
Your response must be concise. 0.82. What is the ratio of the Emissions(in percent) of United Arab Emirates in 2006 to that in 2009?
Offer a terse response. 0.96. What is the ratio of the Emissions(in percent) in Bulgaria in 2006 to that in 2010?
Your answer should be very brief. 1.14. What is the ratio of the Emissions(in percent) in Moldova in 2006 to that in 2010?
Keep it short and to the point. 1.18. What is the ratio of the Emissions(in percent) of Tunisia in 2006 to that in 2010?
Offer a very short reply. 0.74. What is the ratio of the Emissions(in percent) in United Arab Emirates in 2006 to that in 2010?
Ensure brevity in your answer.  0.96. What is the ratio of the Emissions(in percent) of Bulgaria in 2007 to that in 2008?
Your response must be concise. 1.01. What is the ratio of the Emissions(in percent) in Moldova in 2007 to that in 2008?
Ensure brevity in your answer.  1.09. What is the ratio of the Emissions(in percent) of Tunisia in 2007 to that in 2008?
Give a very brief answer. 0.95. What is the ratio of the Emissions(in percent) in United Arab Emirates in 2007 to that in 2008?
Your answer should be compact. 0.99. What is the ratio of the Emissions(in percent) in Bulgaria in 2007 to that in 2009?
Make the answer very short. 1.14. What is the ratio of the Emissions(in percent) of Moldova in 2007 to that in 2009?
Offer a very short reply. 1.13. What is the ratio of the Emissions(in percent) in Tunisia in 2007 to that in 2009?
Your answer should be very brief. 0.91. What is the ratio of the Emissions(in percent) in United Arab Emirates in 2007 to that in 2009?
Offer a terse response. 0.99. What is the ratio of the Emissions(in percent) in Bulgaria in 2007 to that in 2010?
Offer a very short reply. 1.11. What is the ratio of the Emissions(in percent) of Moldova in 2007 to that in 2010?
Offer a very short reply. 1.16. What is the ratio of the Emissions(in percent) of Tunisia in 2007 to that in 2010?
Ensure brevity in your answer.  0.82. What is the ratio of the Emissions(in percent) in Bulgaria in 2008 to that in 2009?
Your response must be concise. 1.13. What is the ratio of the Emissions(in percent) of Moldova in 2008 to that in 2009?
Offer a very short reply. 1.04. What is the ratio of the Emissions(in percent) in Tunisia in 2008 to that in 2009?
Ensure brevity in your answer.  0.96. What is the ratio of the Emissions(in percent) of Bulgaria in 2008 to that in 2010?
Offer a terse response. 1.1. What is the ratio of the Emissions(in percent) in Moldova in 2008 to that in 2010?
Provide a short and direct response. 1.06. What is the ratio of the Emissions(in percent) of Tunisia in 2008 to that in 2010?
Provide a short and direct response. 0.87. What is the ratio of the Emissions(in percent) of United Arab Emirates in 2008 to that in 2010?
Provide a succinct answer. 1. What is the ratio of the Emissions(in percent) in Bulgaria in 2009 to that in 2010?
Offer a terse response. 0.97. What is the ratio of the Emissions(in percent) in Moldova in 2009 to that in 2010?
Offer a very short reply. 1.03. What is the ratio of the Emissions(in percent) in Tunisia in 2009 to that in 2010?
Provide a succinct answer. 0.91. What is the ratio of the Emissions(in percent) of United Arab Emirates in 2009 to that in 2010?
Give a very brief answer. 1. What is the difference between the highest and the second highest Emissions(in percent) in Bulgaria?
Provide a short and direct response. 0.17. What is the difference between the highest and the second highest Emissions(in percent) of Moldova?
Your answer should be compact. 0.37. What is the difference between the highest and the second highest Emissions(in percent) of Tunisia?
Your answer should be very brief. 3.72. What is the difference between the highest and the second highest Emissions(in percent) of United Arab Emirates?
Your answer should be compact. 0.14. What is the difference between the highest and the lowest Emissions(in percent) of Bulgaria?
Provide a succinct answer. 1.97. What is the difference between the highest and the lowest Emissions(in percent) of Moldova?
Provide a succinct answer. 8.12. What is the difference between the highest and the lowest Emissions(in percent) in Tunisia?
Provide a succinct answer. 11.31. What is the difference between the highest and the lowest Emissions(in percent) of United Arab Emirates?
Provide a short and direct response. 2.66. 